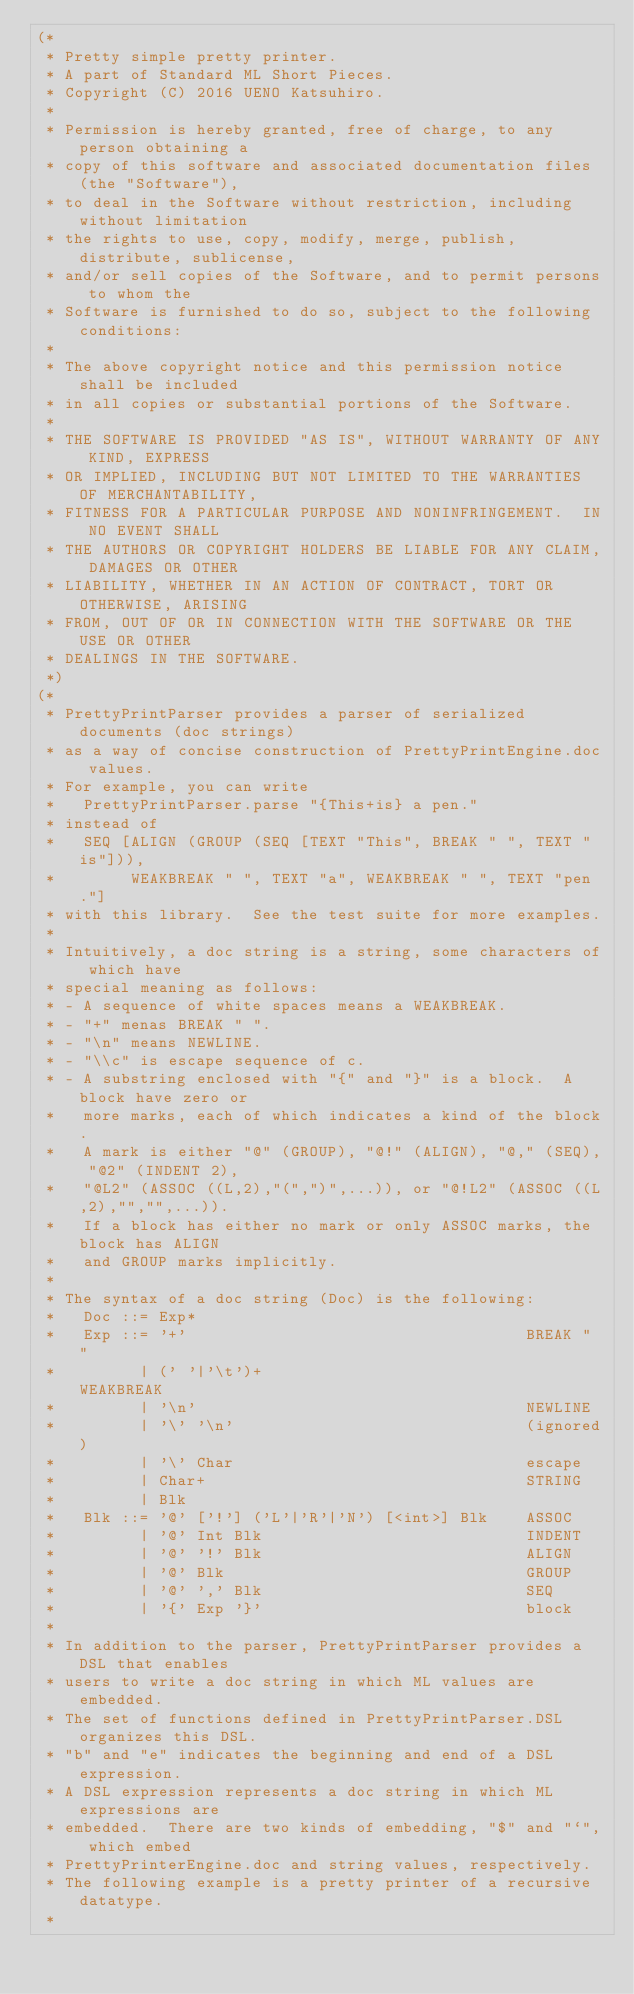Convert code to text. <code><loc_0><loc_0><loc_500><loc_500><_SML_>(*
 * Pretty simple pretty printer.
 * A part of Standard ML Short Pieces.
 * Copyright (C) 2016 UENO Katsuhiro.
 *
 * Permission is hereby granted, free of charge, to any person obtaining a
 * copy of this software and associated documentation files (the "Software"),
 * to deal in the Software without restriction, including without limitation
 * the rights to use, copy, modify, merge, publish, distribute, sublicense,
 * and/or sell copies of the Software, and to permit persons to whom the
 * Software is furnished to do so, subject to the following conditions:
 *
 * The above copyright notice and this permission notice shall be included
 * in all copies or substantial portions of the Software.
 *
 * THE SOFTWARE IS PROVIDED "AS IS", WITHOUT WARRANTY OF ANY KIND, EXPRESS
 * OR IMPLIED, INCLUDING BUT NOT LIMITED TO THE WARRANTIES OF MERCHANTABILITY,
 * FITNESS FOR A PARTICULAR PURPOSE AND NONINFRINGEMENT.  IN NO EVENT SHALL
 * THE AUTHORS OR COPYRIGHT HOLDERS BE LIABLE FOR ANY CLAIM, DAMAGES OR OTHER
 * LIABILITY, WHETHER IN AN ACTION OF CONTRACT, TORT OR OTHERWISE, ARISING
 * FROM, OUT OF OR IN CONNECTION WITH THE SOFTWARE OR THE USE OR OTHER
 * DEALINGS IN THE SOFTWARE.
 *)
(*
 * PrettyPrintParser provides a parser of serialized documents (doc strings)
 * as a way of concise construction of PrettyPrintEngine.doc values.
 * For example, you can write
 *   PrettyPrintParser.parse "{This+is} a pen."
 * instead of
 *   SEQ [ALIGN (GROUP (SEQ [TEXT "This", BREAK " ", TEXT "is"])),
 *        WEAKBREAK " ", TEXT "a", WEAKBREAK " ", TEXT "pen."]
 * with this library.  See the test suite for more examples.
 *
 * Intuitively, a doc string is a string, some characters of which have
 * special meaning as follows:
 * - A sequence of white spaces means a WEAKBREAK.
 * - "+" menas BREAK " ".
 * - "\n" means NEWLINE.
 * - "\\c" is escape sequence of c.
 * - A substring enclosed with "{" and "}" is a block.  A block have zero or
 *   more marks, each of which indicates a kind of the block.
 *   A mark is either "@" (GROUP), "@!" (ALIGN), "@," (SEQ), "@2" (INDENT 2),
 *   "@L2" (ASSOC ((L,2),"(",")",...)), or "@!L2" (ASSOC ((L,2),"","",...)).
 *   If a block has either no mark or only ASSOC marks, the block has ALIGN
 *   and GROUP marks implicitly.
 *
 * The syntax of a doc string (Doc) is the following:
 *   Doc ::= Exp*
 *   Exp ::= '+'                                    BREAK " "
 *         | (' '|'\t')+                            WEAKBREAK
 *         | '\n'                                   NEWLINE
 *         | '\' '\n'                               (ignored)
 *         | '\' Char                               escape
 *         | Char+                                  STRING
 *         | Blk
 *   Blk ::= '@' ['!'] ('L'|'R'|'N') [<int>] Blk    ASSOC
 *         | '@' Int Blk                            INDENT
 *         | '@' '!' Blk                            ALIGN
 *         | '@' Blk                                GROUP
 *         | '@' ',' Blk                            SEQ
 *         | '{' Exp '}'                            block
 *
 * In addition to the parser, PrettyPrintParser provides a DSL that enables
 * users to write a doc string in which ML values are embedded.
 * The set of functions defined in PrettyPrintParser.DSL organizes this DSL.
 * "b" and "e" indicates the beginning and end of a DSL expression.
 * A DSL expression represents a doc string in which ML expressions are
 * embedded.  There are two kinds of embedding, "$" and "`", which embed
 * PrettyPrinterEngine.doc and string values, respectively.
 * The following example is a pretty printer of a recursive datatype.
 *</code> 